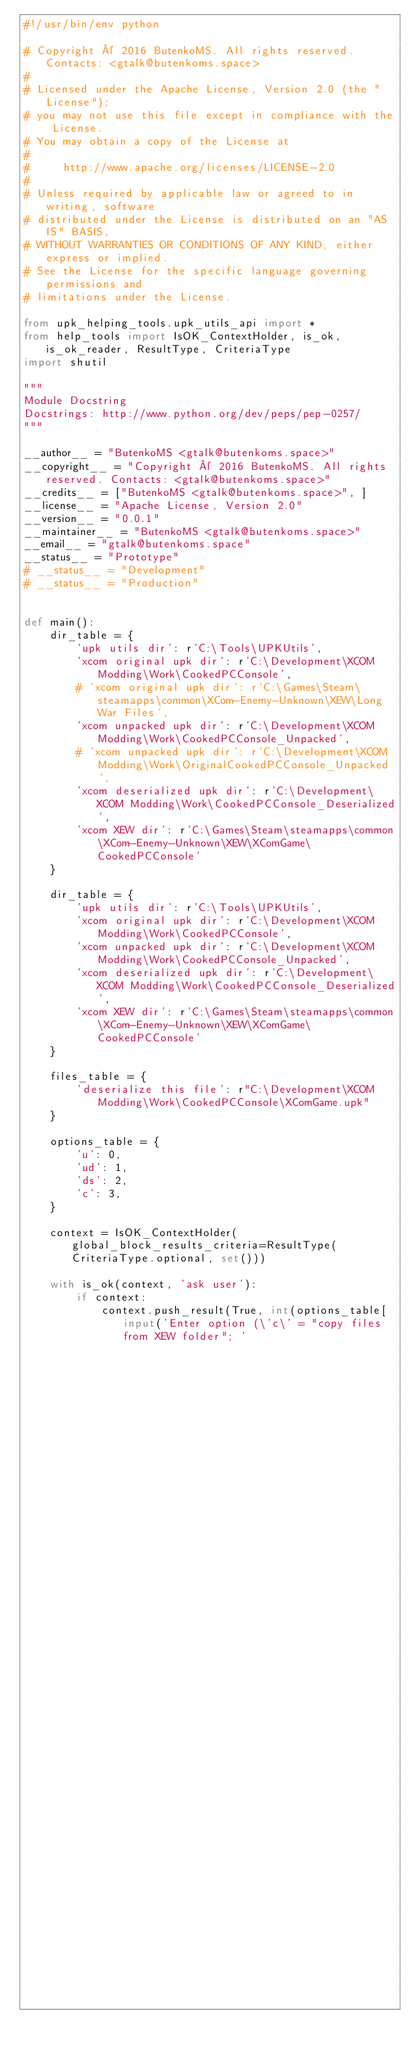<code> <loc_0><loc_0><loc_500><loc_500><_Python_>#!/usr/bin/env python

# Copyright © 2016 ButenkoMS. All rights reserved. Contacts: <gtalk@butenkoms.space>
#
# Licensed under the Apache License, Version 2.0 (the "License");
# you may not use this file except in compliance with the License.
# You may obtain a copy of the License at
#
#     http://www.apache.org/licenses/LICENSE-2.0
#
# Unless required by applicable law or agreed to in writing, software
# distributed under the License is distributed on an "AS IS" BASIS,
# WITHOUT WARRANTIES OR CONDITIONS OF ANY KIND, either express or implied.
# See the License for the specific language governing permissions and
# limitations under the License.

from upk_helping_tools.upk_utils_api import *
from help_tools import IsOK_ContextHolder, is_ok, is_ok_reader, ResultType, CriteriaType
import shutil

"""
Module Docstring
Docstrings: http://www.python.org/dev/peps/pep-0257/
"""

__author__ = "ButenkoMS <gtalk@butenkoms.space>"
__copyright__ = "Copyright © 2016 ButenkoMS. All rights reserved. Contacts: <gtalk@butenkoms.space>"
__credits__ = ["ButenkoMS <gtalk@butenkoms.space>", ]
__license__ = "Apache License, Version 2.0"
__version__ = "0.0.1"
__maintainer__ = "ButenkoMS <gtalk@butenkoms.space>"
__email__ = "gtalk@butenkoms.space"
__status__ = "Prototype"
# __status__ = "Development"
# __status__ = "Production"


def main():
    dir_table = {
        'upk utils dir': r'C:\Tools\UPKUtils',
        'xcom original upk dir': r'C:\Development\XCOM Modding\Work\CookedPCConsole',
        # 'xcom original upk dir': r'C:\Games\Steam\steamapps\common\XCom-Enemy-Unknown\XEW\Long War Files',
        'xcom unpacked upk dir': r'C:\Development\XCOM Modding\Work\CookedPCConsole_Unpacked',
        # 'xcom unpacked upk dir': r'C:\Development\XCOM Modding\Work\OriginalCookedPCConsole_Unpacked',
        'xcom deserialized upk dir': r'C:\Development\XCOM Modding\Work\CookedPCConsole_Deserialized',
        'xcom XEW dir': r'C:\Games\Steam\steamapps\common\XCom-Enemy-Unknown\XEW\XComGame\CookedPCConsole'
    }

    dir_table = {
        'upk utils dir': r'C:\Tools\UPKUtils',
        'xcom original upk dir': r'C:\Development\XCOM Modding\Work\CookedPCConsole',
        'xcom unpacked upk dir': r'C:\Development\XCOM Modding\Work\CookedPCConsole_Unpacked',
        'xcom deserialized upk dir': r'C:\Development\XCOM Modding\Work\CookedPCConsole_Deserialized',
        'xcom XEW dir': r'C:\Games\Steam\steamapps\common\XCom-Enemy-Unknown\XEW\XComGame\CookedPCConsole'
    }

    files_table = {
        'deserialize this file': r"C:\Development\XCOM Modding\Work\CookedPCConsole\XComGame.upk"
    }

    options_table = {
        'u': 0,
        'ud': 1,
        'ds': 2,
        'c': 3,
    }

    context = IsOK_ContextHolder(global_block_results_criteria=ResultType(CriteriaType.optional, set()))

    with is_ok(context, 'ask user'):
        if context:
            context.push_result(True, int(options_table[input('Enter option (\'c\' = "copy files from XEW folder"; '
                                                              '\'u\' = "unpack"; '
                                                              '\'ud\' = "unpack + deserialize"; '
                                                              '\'ds\' = "deserialize single file"): ')]))
</code> 